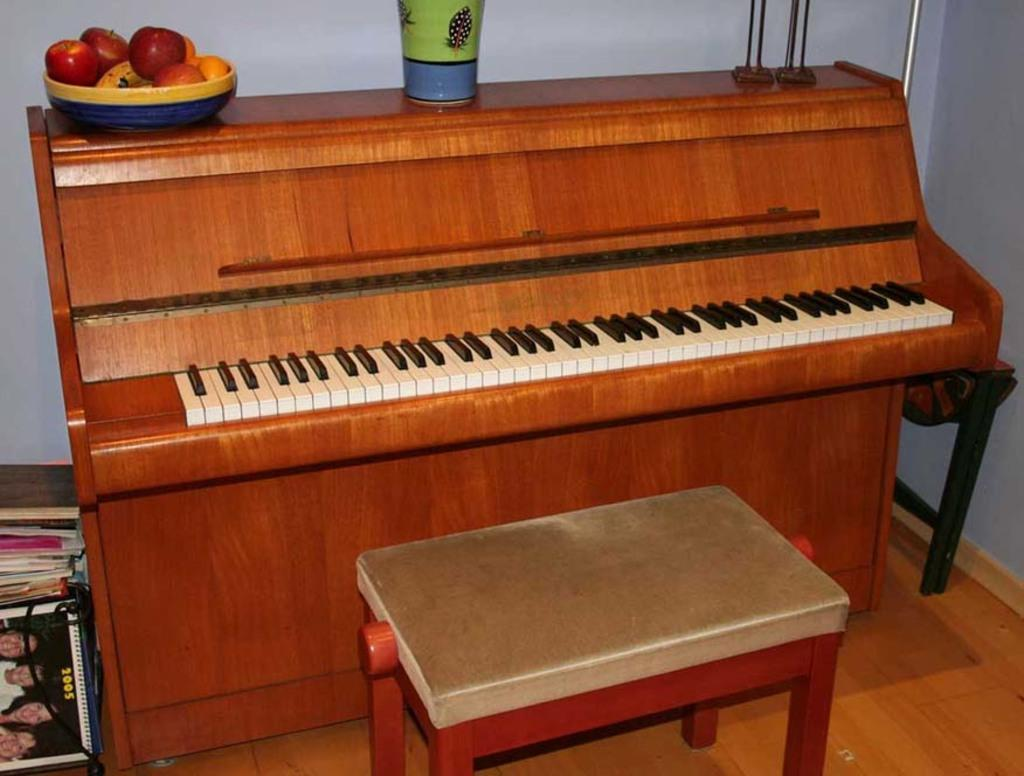What type of musical instrument is in the image? There is a wooden piano in the image. What is placed in front of the piano? There is a small chair in front of the piano. What items can be seen on top of the piano? There is a basket of fruits and a beautifully designed vase on the piano. How many frogs are sitting on the piano in the image? There are no frogs present in the image; the only items on the piano are a basket of fruits and a beautifully designed vase. 